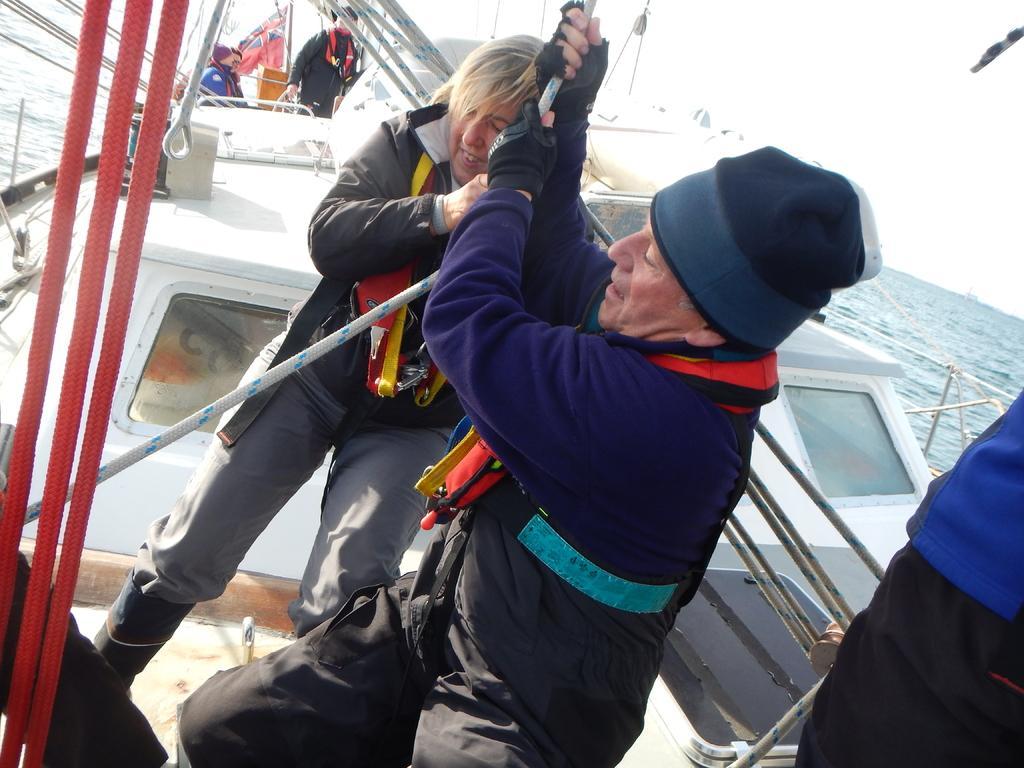In one or two sentences, can you explain what this image depicts? In this image we can see few persons are on a ship and among them two persons are holding a rope in their hands and there are objects. In the background we can see poles, water and the sky. 